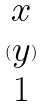<formula> <loc_0><loc_0><loc_500><loc_500>( \begin{matrix} x \\ y \\ 1 \end{matrix} )</formula> 